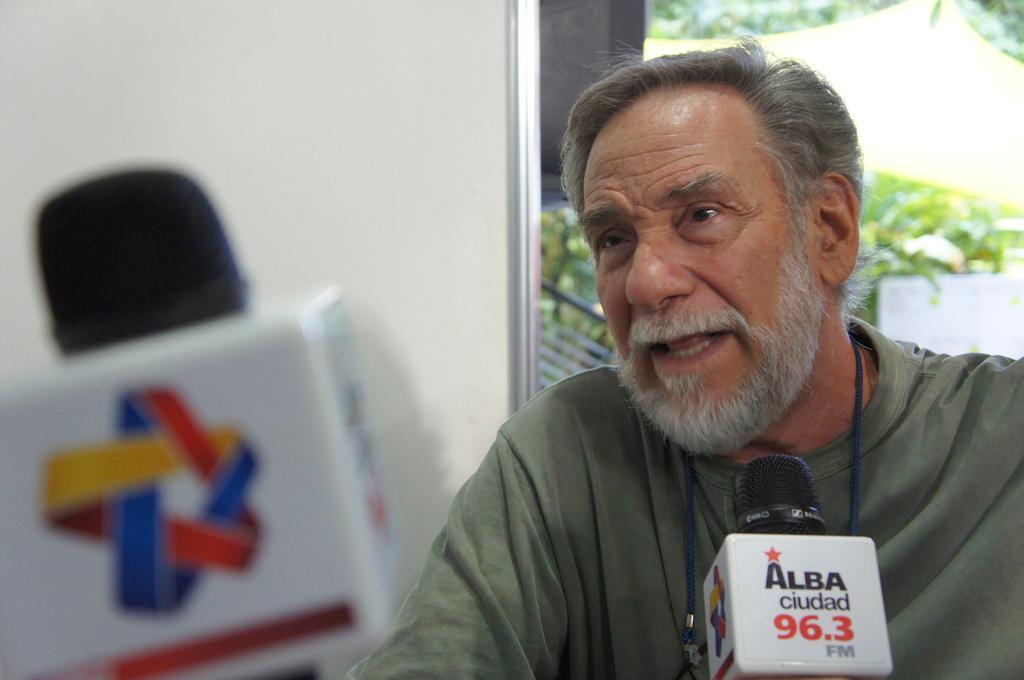Can you describe this image briefly? In this picture we can see a mic and a man talking on a mic and in the background we can see a board, trees. 